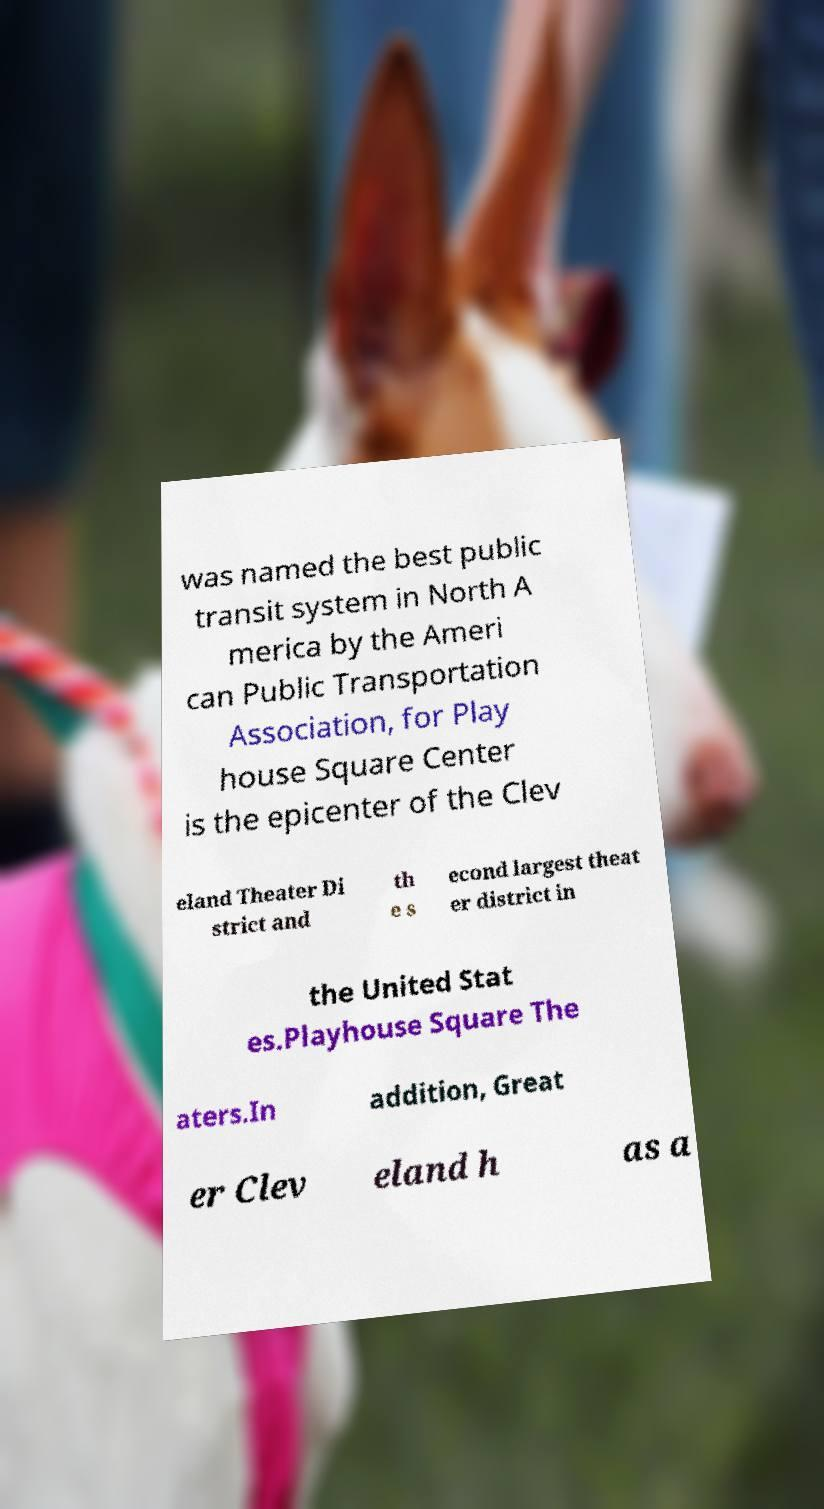What messages or text are displayed in this image? I need them in a readable, typed format. was named the best public transit system in North A merica by the Ameri can Public Transportation Association, for Play house Square Center is the epicenter of the Clev eland Theater Di strict and th e s econd largest theat er district in the United Stat es.Playhouse Square The aters.In addition, Great er Clev eland h as a 